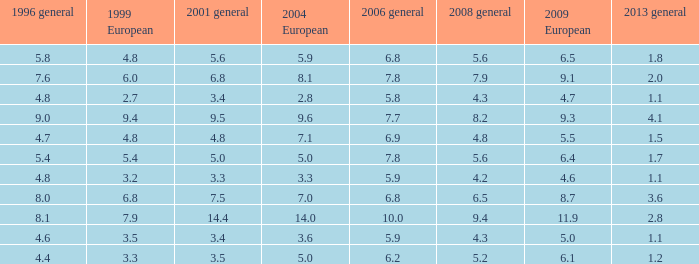Could you help me parse every detail presented in this table? {'header': ['1996 general', '1999 European', '2001 general', '2004 European', '2006 general', '2008 general', '2009 European', '2013 general'], 'rows': [['5.8', '4.8', '5.6', '5.9', '6.8', '5.6', '6.5', '1.8'], ['7.6', '6.0', '6.8', '8.1', '7.8', '7.9', '9.1', '2.0'], ['4.8', '2.7', '3.4', '2.8', '5.8', '4.3', '4.7', '1.1'], ['9.0', '9.4', '9.5', '9.6', '7.7', '8.2', '9.3', '4.1'], ['4.7', '4.8', '4.8', '7.1', '6.9', '4.8', '5.5', '1.5'], ['5.4', '5.4', '5.0', '5.0', '7.8', '5.6', '6.4', '1.7'], ['4.8', '3.2', '3.3', '3.3', '5.9', '4.2', '4.6', '1.1'], ['8.0', '6.8', '7.5', '7.0', '6.8', '6.5', '8.7', '3.6'], ['8.1', '7.9', '14.4', '14.0', '10.0', '9.4', '11.9', '2.8'], ['4.6', '3.5', '3.4', '3.6', '5.9', '4.3', '5.0', '1.1'], ['4.4', '3.3', '3.5', '5.0', '6.2', '5.2', '6.1', '1.2']]} What is the highest value for general 2008 when there is less than 5.5 in European 2009, more than 5.8 in general 2006, more than 3.3 in general 2001, and less than 3.6 for 2004 European? None. 